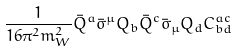Convert formula to latex. <formula><loc_0><loc_0><loc_500><loc_500>\frac { 1 } { 1 6 \pi ^ { 2 } m _ { W } ^ { 2 } } \bar { Q } ^ { a } \bar { \sigma } ^ { \mu } Q _ { b } \bar { Q } ^ { c } \bar { \sigma } _ { \mu } Q _ { d } C _ { b d } ^ { a c }</formula> 